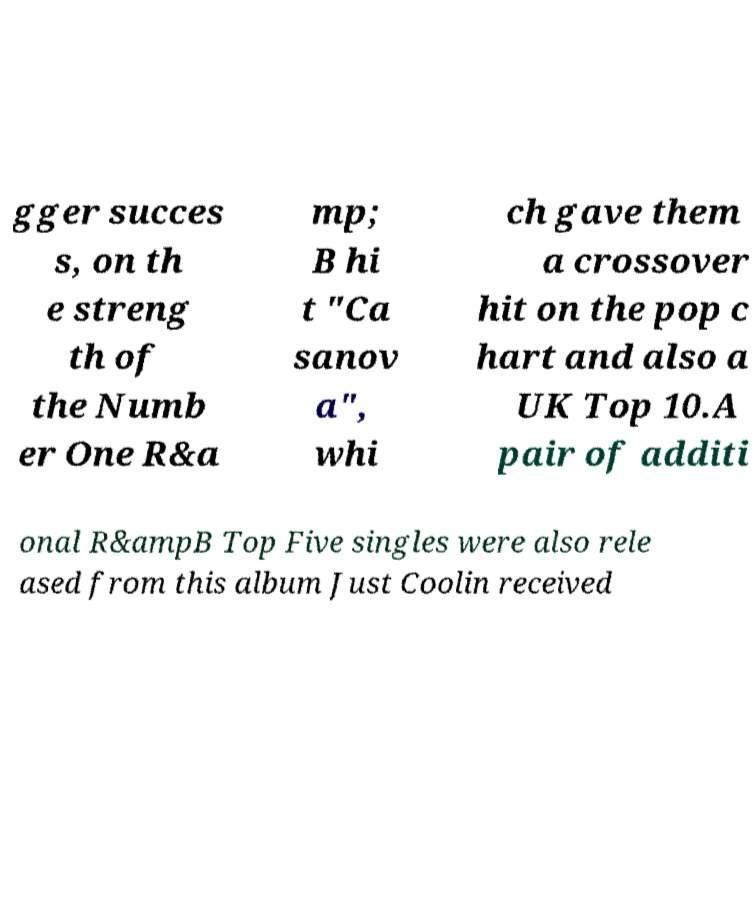Could you assist in decoding the text presented in this image and type it out clearly? gger succes s, on th e streng th of the Numb er One R&a mp; B hi t "Ca sanov a", whi ch gave them a crossover hit on the pop c hart and also a UK Top 10.A pair of additi onal R&ampB Top Five singles were also rele ased from this album Just Coolin received 